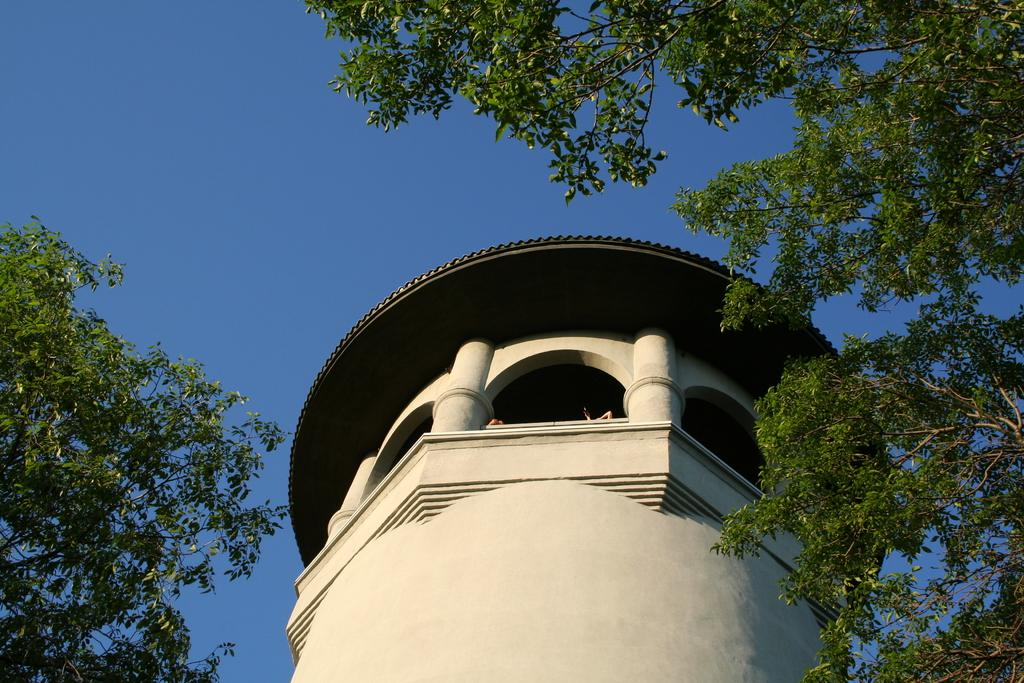What is the main structure in the image? There is a building in the image. What can be seen in the background of the image? There are trees and the sky visible in the background of the image. What type of pear is being used as a plough in the meeting depicted in the image? There is no pear, plough, or meeting present in the image. 